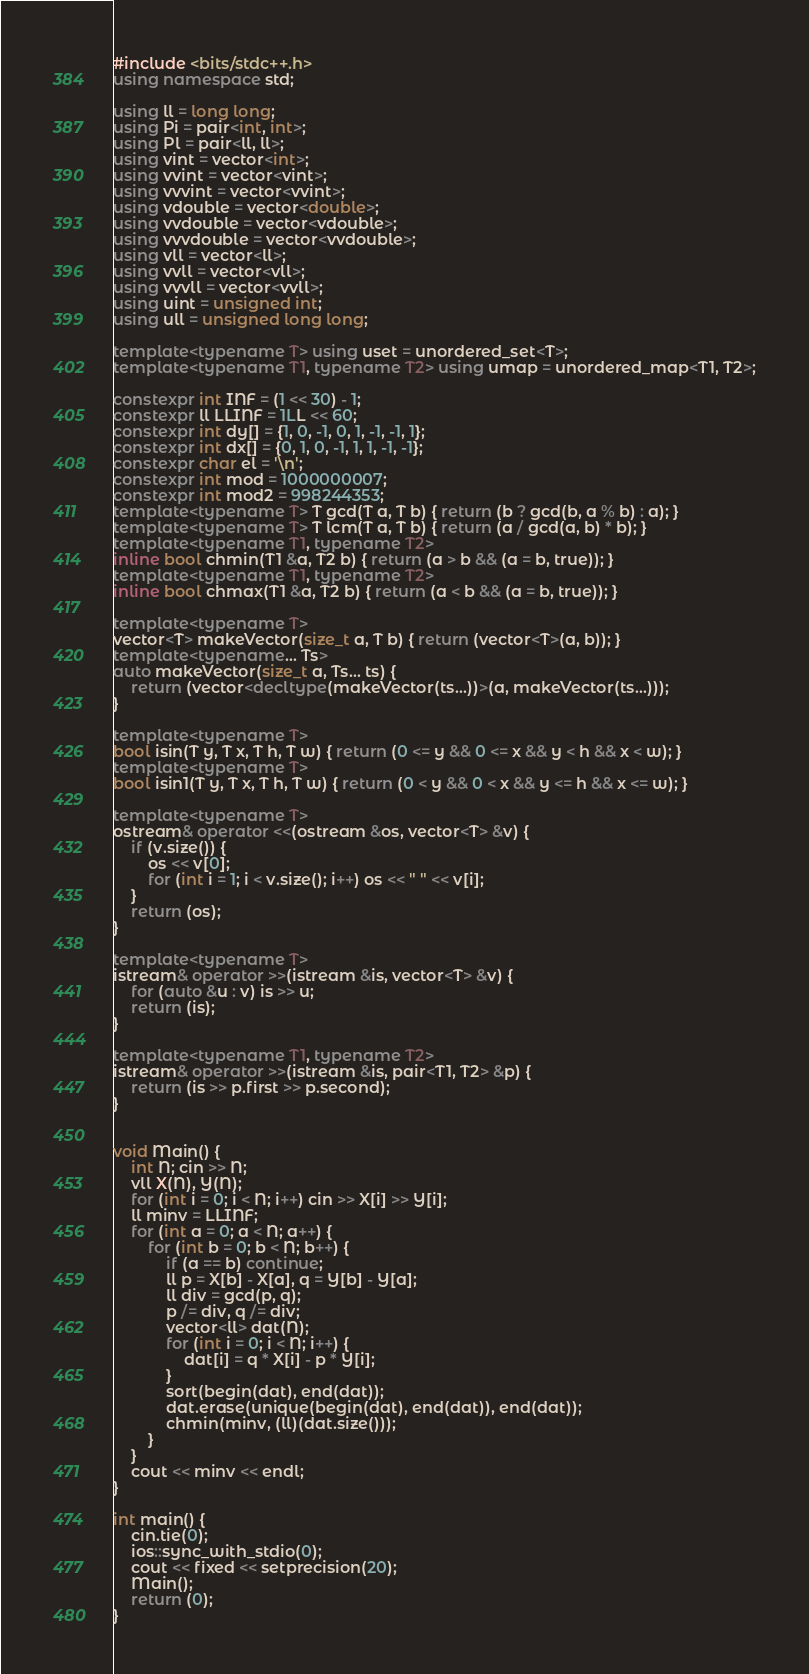<code> <loc_0><loc_0><loc_500><loc_500><_C++_>#include <bits/stdc++.h>
using namespace std;

using ll = long long;
using Pi = pair<int, int>;
using Pl = pair<ll, ll>;
using vint = vector<int>;
using vvint = vector<vint>;
using vvvint = vector<vvint>;
using vdouble = vector<double>;
using vvdouble = vector<vdouble>;
using vvvdouble = vector<vvdouble>;
using vll = vector<ll>;
using vvll = vector<vll>;
using vvvll = vector<vvll>;
using uint = unsigned int;
using ull = unsigned long long;

template<typename T> using uset = unordered_set<T>;
template<typename T1, typename T2> using umap = unordered_map<T1, T2>;

constexpr int INF = (1 << 30) - 1;
constexpr ll LLINF = 1LL << 60;
constexpr int dy[] = {1, 0, -1, 0, 1, -1, -1, 1};
constexpr int dx[] = {0, 1, 0, -1, 1, 1, -1, -1};
constexpr char el = '\n';
constexpr int mod = 1000000007;
constexpr int mod2 = 998244353;
template<typename T> T gcd(T a, T b) { return (b ? gcd(b, a % b) : a); }
template<typename T> T lcm(T a, T b) { return (a / gcd(a, b) * b); }
template<typename T1, typename T2>
inline bool chmin(T1 &a, T2 b) { return (a > b && (a = b, true)); }
template<typename T1, typename T2>
inline bool chmax(T1 &a, T2 b) { return (a < b && (a = b, true)); }

template<typename T>
vector<T> makeVector(size_t a, T b) { return (vector<T>(a, b)); }
template<typename... Ts>
auto makeVector(size_t a, Ts... ts) { 
	return (vector<decltype(makeVector(ts...))>(a, makeVector(ts...)));
}

template<typename T>
bool isin(T y, T x, T h, T w) { return (0 <= y && 0 <= x && y < h && x < w); }
template<typename T>
bool isin1(T y, T x, T h, T w) { return (0 < y && 0 < x && y <= h && x <= w); }

template<typename T>
ostream& operator <<(ostream &os, vector<T> &v) {
	if (v.size()) {
		os << v[0];
		for (int i = 1; i < v.size(); i++) os << " " << v[i];
	}
	return (os);
}

template<typename T>
istream& operator >>(istream &is, vector<T> &v) {
	for (auto &u : v) is >> u;
	return (is);
}

template<typename T1, typename T2>
istream& operator >>(istream &is, pair<T1, T2> &p) {
	return (is >> p.first >> p.second);
}


void Main() {
	int N; cin >> N;
	vll X(N), Y(N);
	for (int i = 0; i < N; i++) cin >> X[i] >> Y[i];
	ll minv = LLINF;
	for (int a = 0; a < N; a++) {
		for (int b = 0; b < N; b++) {
			if (a == b) continue;
			ll p = X[b] - X[a], q = Y[b] - Y[a];
			ll div = gcd(p, q);
			p /= div, q /= div;
			vector<ll> dat(N);
			for (int i = 0; i < N; i++) {
				dat[i] = q * X[i] - p * Y[i];
			}
			sort(begin(dat), end(dat));
			dat.erase(unique(begin(dat), end(dat)), end(dat));
			chmin(minv, (ll)(dat.size()));
		}
	}
	cout << minv << endl;
}

int main() {
	cin.tie(0);
	ios::sync_with_stdio(0);
	cout << fixed << setprecision(20);
	Main();
	return (0);
}
</code> 